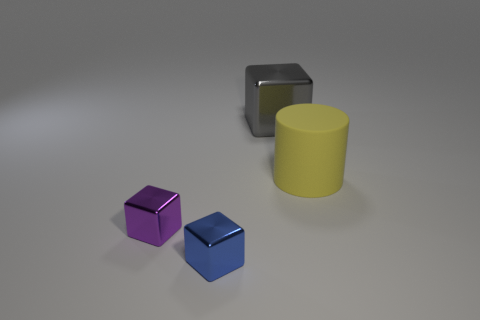What number of things are either brown matte things or things?
Make the answer very short. 4. How many tiny blue things are the same shape as the small purple object?
Ensure brevity in your answer.  1. Is the material of the big gray object the same as the tiny thing that is behind the tiny blue object?
Keep it short and to the point. Yes. There is a purple object that is the same material as the gray block; what size is it?
Provide a short and direct response. Small. What size is the thing that is in front of the purple object?
Offer a terse response. Small. How many other yellow matte things are the same size as the rubber thing?
Ensure brevity in your answer.  0. Is there a rubber cylinder of the same color as the big cube?
Provide a short and direct response. No. What is the color of the rubber cylinder that is the same size as the gray metal block?
Give a very brief answer. Yellow. Do the large matte thing and the object behind the yellow cylinder have the same color?
Offer a terse response. No. The rubber cylinder is what color?
Ensure brevity in your answer.  Yellow. 